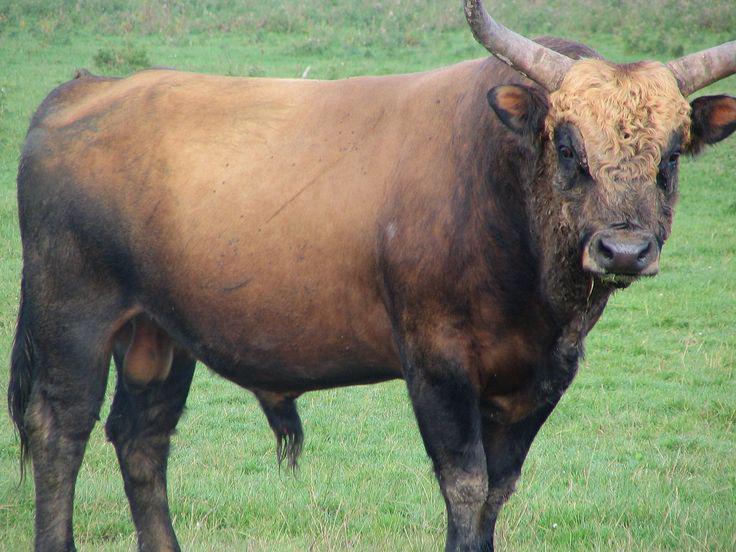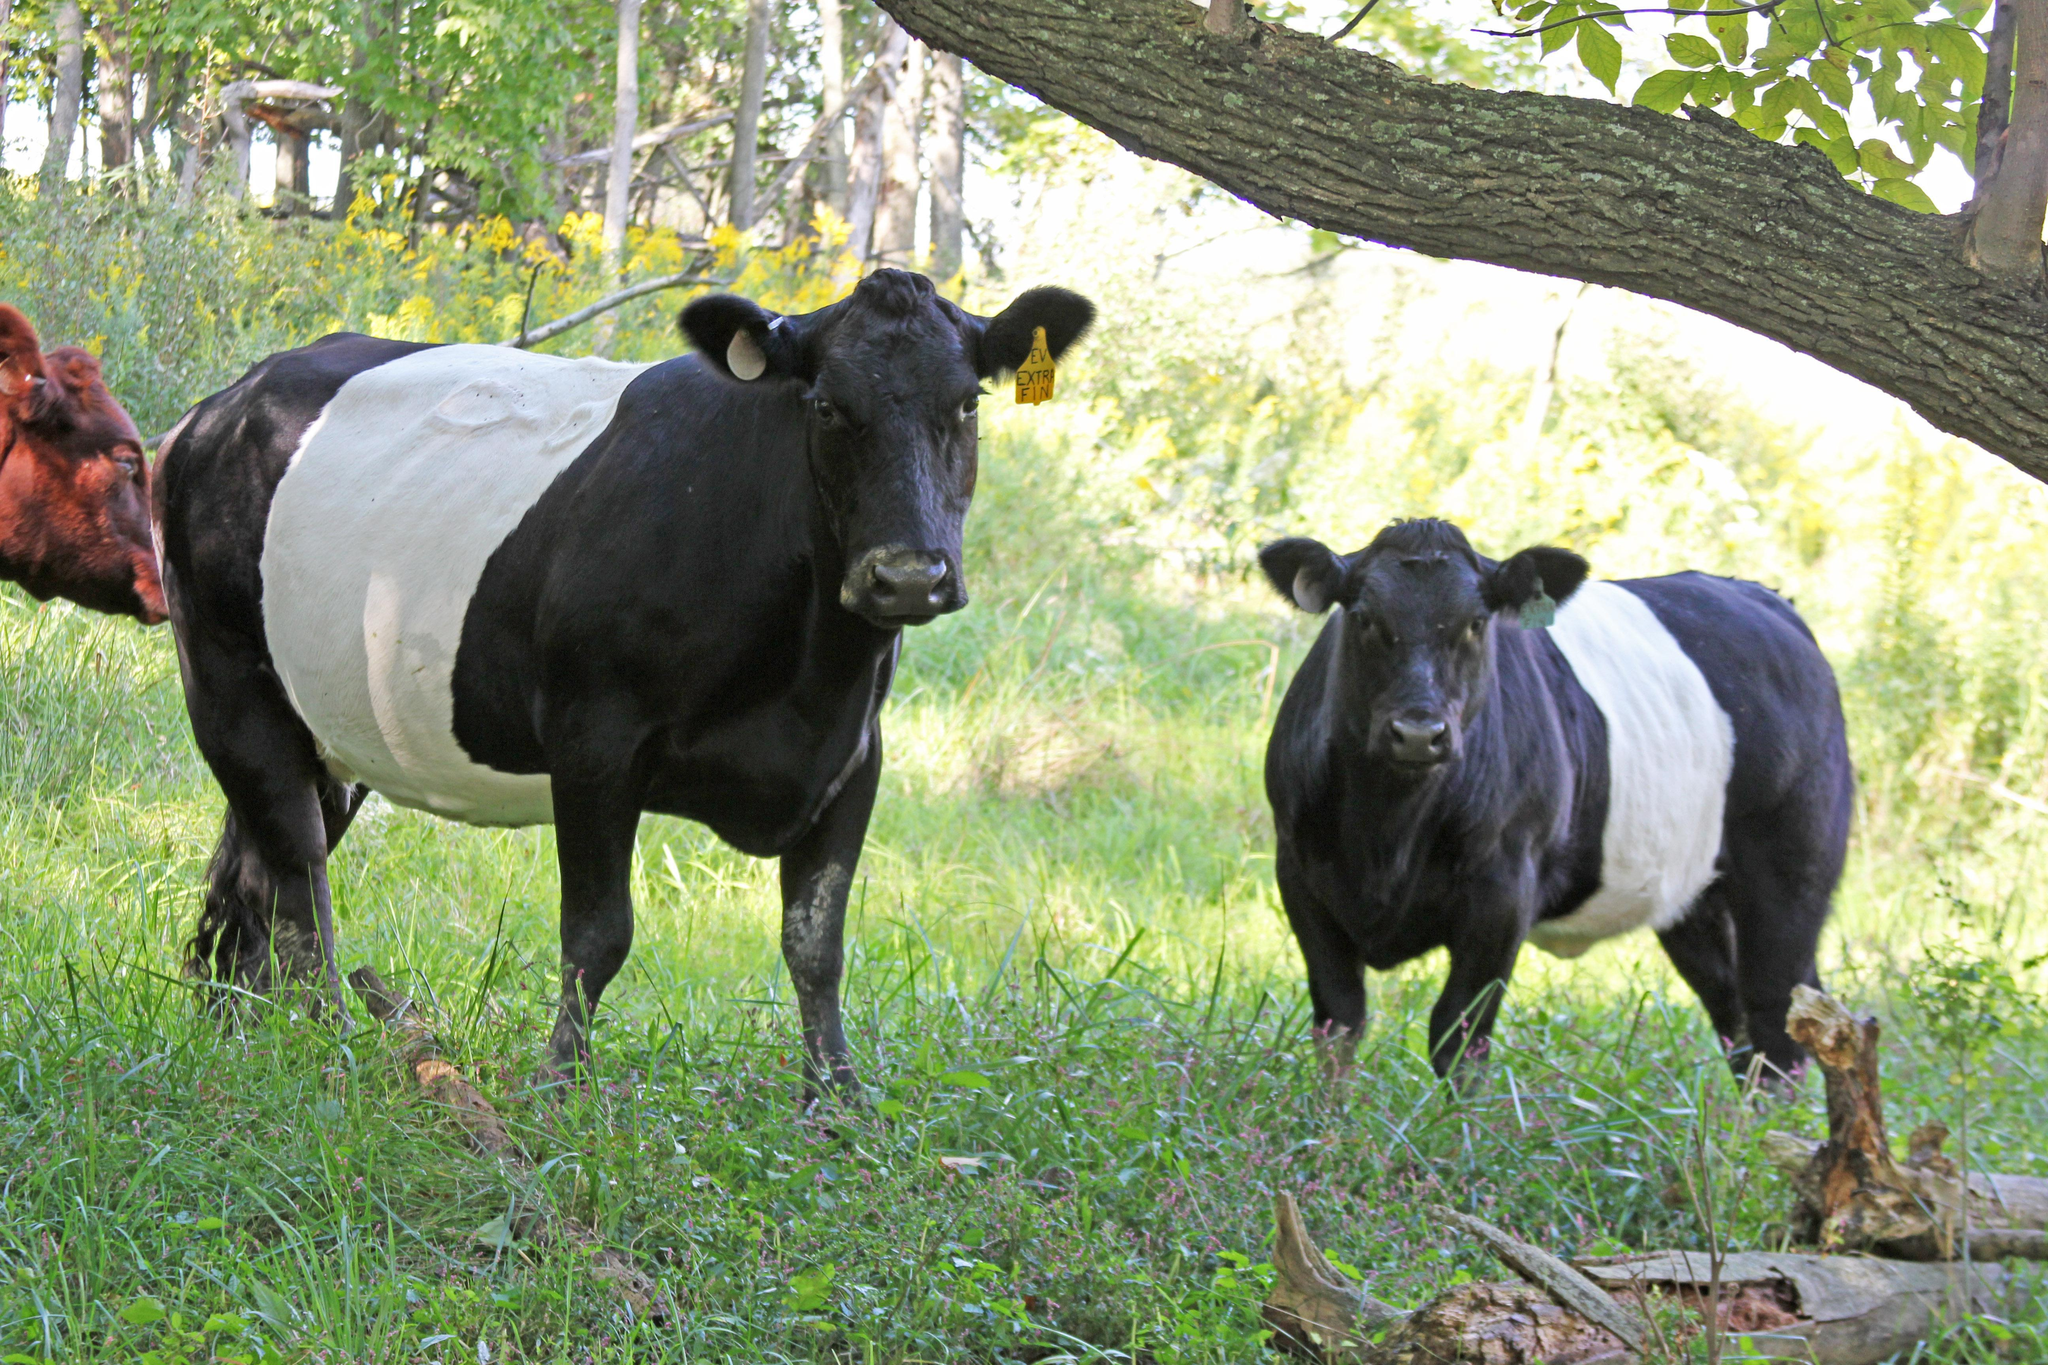The first image is the image on the left, the second image is the image on the right. Examine the images to the left and right. Is the description "One image includes at least two cattle." accurate? Answer yes or no. Yes. 